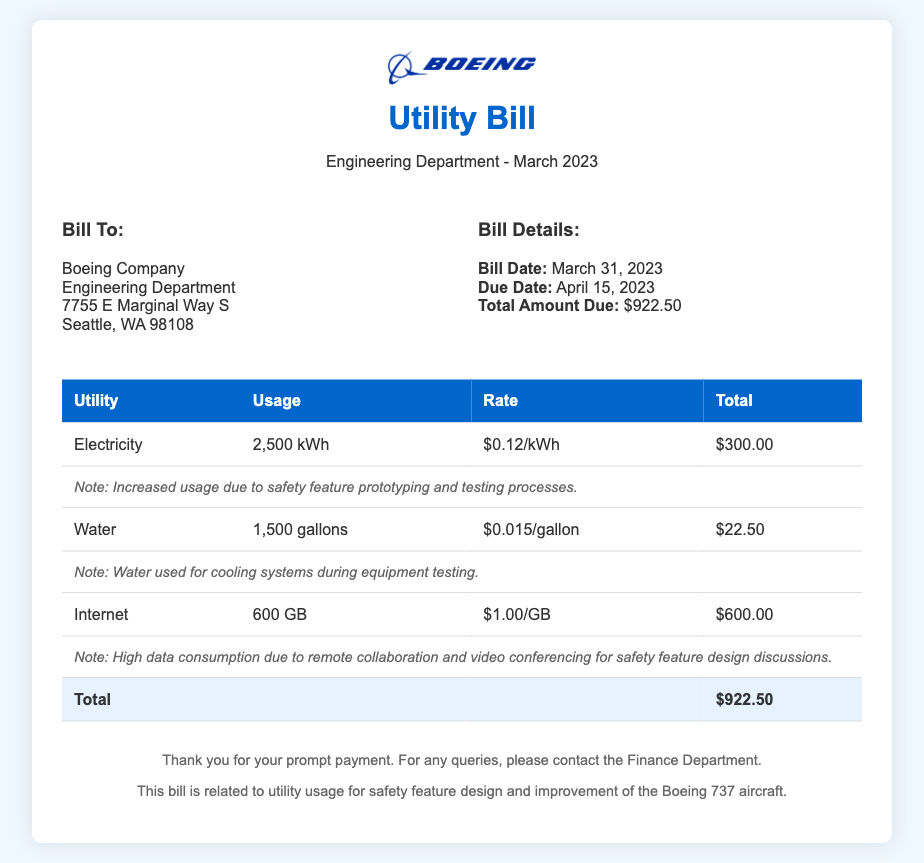What is the total amount due? The total amount due is stated in the bill details section, which shows the total to be $922.50.
Answer: $922.50 What is the usage of electricity? The electricity usage is listed in the utility table as 2,500 kWh.
Answer: 2,500 kWh What is the rate for water? The rate for water is provided in the utility table as $0.015 per gallon.
Answer: $0.015/gallon What is the note associated with the electricity usage? The note mentions that there was increased usage due to safety feature prototyping and testing processes.
Answer: Increased usage due to safety feature prototyping and testing processes How much water was used? The water usage is indicated in the utility table as 1,500 gallons.
Answer: 1,500 gallons What is the billing date? The billing date is noted in the bill details section as March 31, 2023.
Answer: March 31, 2023 How much internet was used? The internet usage is recorded in the utility table as 600 GB.
Answer: 600 GB What is the purpose of the high internet usage? The note explains that high data consumption is due to remote collaboration and video conferencing for safety feature design discussions.
Answer: Remote collaboration and video conferencing for safety feature design discussions What is the total charge for internet? The total charge for internet usage is provided in the utility table as $600.00.
Answer: $600.00 